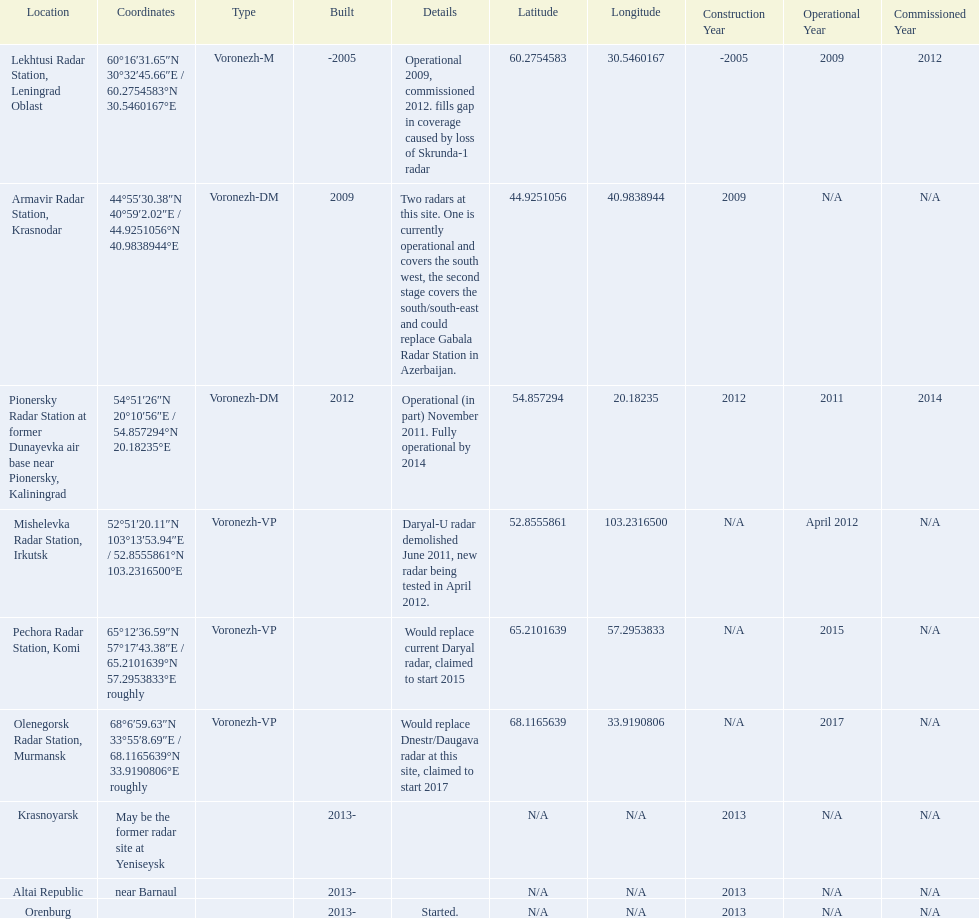What are the list of radar locations? Lekhtusi Radar Station, Leningrad Oblast, Armavir Radar Station, Krasnodar, Pionersky Radar Station at former Dunayevka air base near Pionersky, Kaliningrad, Mishelevka Radar Station, Irkutsk, Pechora Radar Station, Komi, Olenegorsk Radar Station, Murmansk, Krasnoyarsk, Altai Republic, Orenburg. Which of these are claimed to start in 2015? Pechora Radar Station, Komi. 